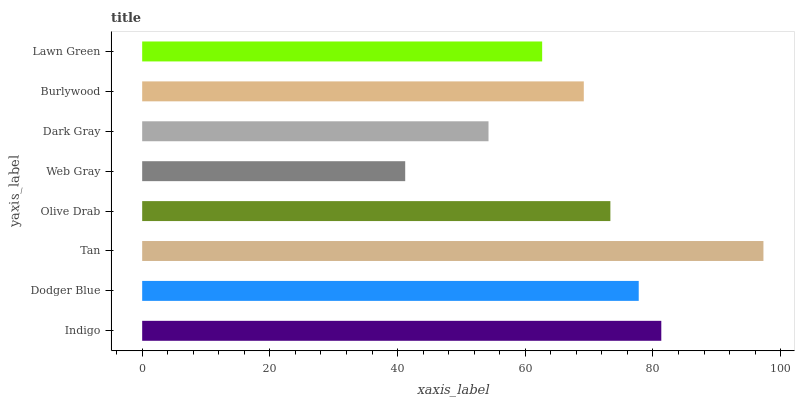Is Web Gray the minimum?
Answer yes or no. Yes. Is Tan the maximum?
Answer yes or no. Yes. Is Dodger Blue the minimum?
Answer yes or no. No. Is Dodger Blue the maximum?
Answer yes or no. No. Is Indigo greater than Dodger Blue?
Answer yes or no. Yes. Is Dodger Blue less than Indigo?
Answer yes or no. Yes. Is Dodger Blue greater than Indigo?
Answer yes or no. No. Is Indigo less than Dodger Blue?
Answer yes or no. No. Is Olive Drab the high median?
Answer yes or no. Yes. Is Burlywood the low median?
Answer yes or no. Yes. Is Web Gray the high median?
Answer yes or no. No. Is Dark Gray the low median?
Answer yes or no. No. 